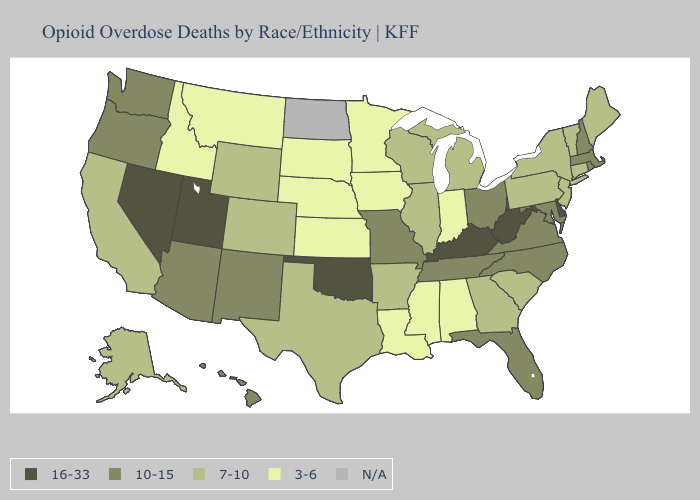Among the states that border Kansas , does Missouri have the highest value?
Keep it brief. No. Does Washington have the lowest value in the USA?
Concise answer only. No. What is the value of West Virginia?
Concise answer only. 16-33. Name the states that have a value in the range 16-33?
Short answer required. Delaware, Kentucky, Nevada, Oklahoma, Utah, West Virginia. Name the states that have a value in the range 10-15?
Keep it brief. Arizona, Florida, Hawaii, Maryland, Massachusetts, Missouri, New Hampshire, New Mexico, North Carolina, Ohio, Oregon, Rhode Island, Tennessee, Virginia, Washington. Name the states that have a value in the range N/A?
Answer briefly. North Dakota. Name the states that have a value in the range 16-33?
Keep it brief. Delaware, Kentucky, Nevada, Oklahoma, Utah, West Virginia. Is the legend a continuous bar?
Concise answer only. No. What is the lowest value in states that border Rhode Island?
Be succinct. 7-10. What is the highest value in the USA?
Be succinct. 16-33. Does Mississippi have the lowest value in the USA?
Give a very brief answer. Yes. Name the states that have a value in the range 16-33?
Short answer required. Delaware, Kentucky, Nevada, Oklahoma, Utah, West Virginia. What is the highest value in the MidWest ?
Answer briefly. 10-15. What is the highest value in the MidWest ?
Short answer required. 10-15. 